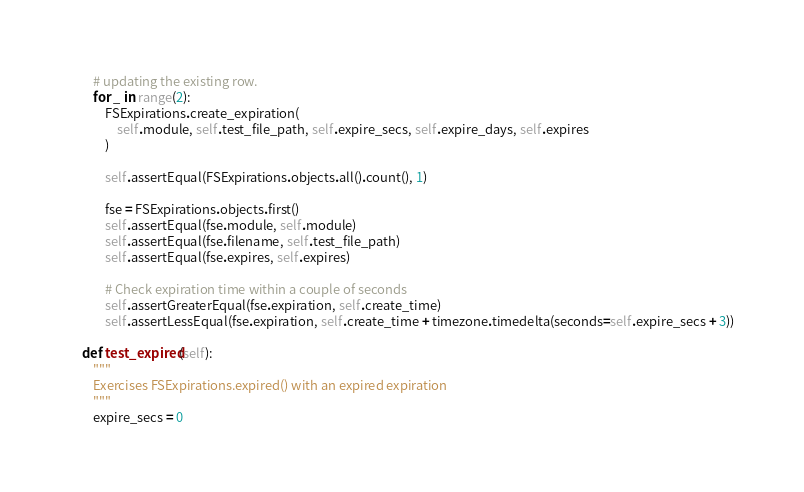<code> <loc_0><loc_0><loc_500><loc_500><_Python_>        # updating the existing row.
        for _ in range(2):
            FSExpirations.create_expiration(
                self.module, self.test_file_path, self.expire_secs, self.expire_days, self.expires
            )

            self.assertEqual(FSExpirations.objects.all().count(), 1)

            fse = FSExpirations.objects.first()
            self.assertEqual(fse.module, self.module)
            self.assertEqual(fse.filename, self.test_file_path)
            self.assertEqual(fse.expires, self.expires)

            # Check expiration time within a couple of seconds
            self.assertGreaterEqual(fse.expiration, self.create_time)
            self.assertLessEqual(fse.expiration, self.create_time + timezone.timedelta(seconds=self.expire_secs + 3))

    def test_expired(self):
        """
        Exercises FSExpirations.expired() with an expired expiration
        """
        expire_secs = 0</code> 